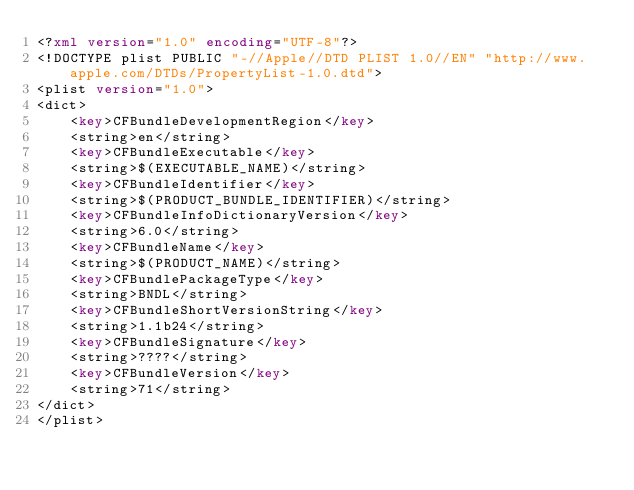Convert code to text. <code><loc_0><loc_0><loc_500><loc_500><_XML_><?xml version="1.0" encoding="UTF-8"?>
<!DOCTYPE plist PUBLIC "-//Apple//DTD PLIST 1.0//EN" "http://www.apple.com/DTDs/PropertyList-1.0.dtd">
<plist version="1.0">
<dict>
	<key>CFBundleDevelopmentRegion</key>
	<string>en</string>
	<key>CFBundleExecutable</key>
	<string>$(EXECUTABLE_NAME)</string>
	<key>CFBundleIdentifier</key>
	<string>$(PRODUCT_BUNDLE_IDENTIFIER)</string>
	<key>CFBundleInfoDictionaryVersion</key>
	<string>6.0</string>
	<key>CFBundleName</key>
	<string>$(PRODUCT_NAME)</string>
	<key>CFBundlePackageType</key>
	<string>BNDL</string>
	<key>CFBundleShortVersionString</key>
	<string>1.1b24</string>
	<key>CFBundleSignature</key>
	<string>????</string>
	<key>CFBundleVersion</key>
	<string>71</string>
</dict>
</plist>
</code> 